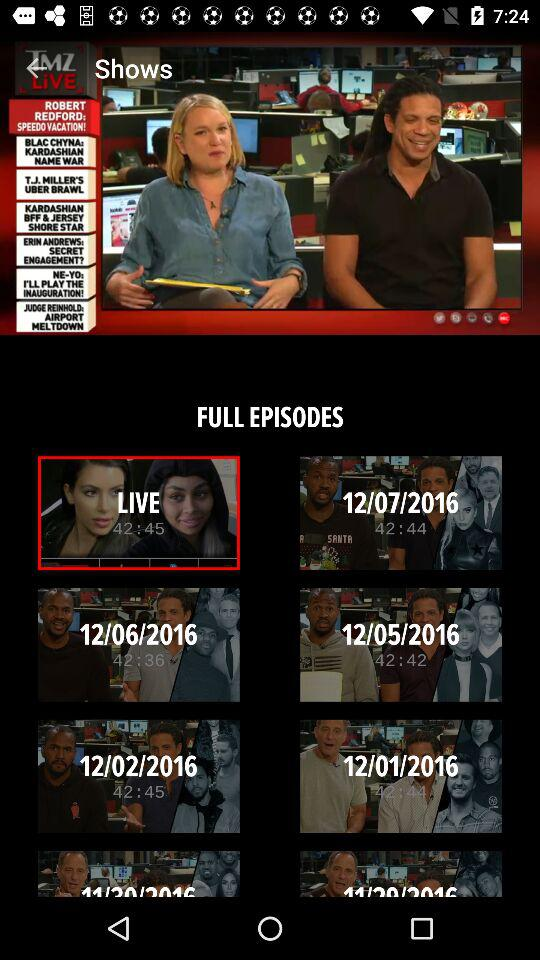What is the duration of the episode for which you are selected as live? The duration is 42:45. 